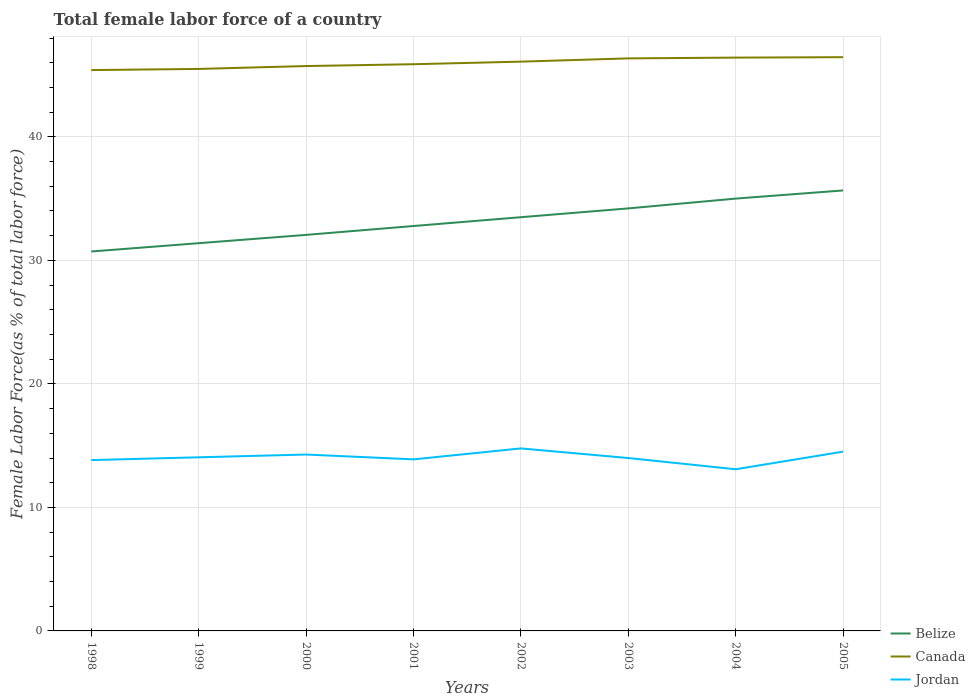Across all years, what is the maximum percentage of female labor force in Belize?
Provide a short and direct response. 30.72. In which year was the percentage of female labor force in Jordan maximum?
Your answer should be very brief. 2004. What is the total percentage of female labor force in Jordan in the graph?
Offer a terse response. -0.52. What is the difference between the highest and the second highest percentage of female labor force in Canada?
Provide a succinct answer. 1.04. What is the difference between the highest and the lowest percentage of female labor force in Canada?
Your answer should be compact. 4. Is the percentage of female labor force in Jordan strictly greater than the percentage of female labor force in Canada over the years?
Provide a short and direct response. Yes. What is the difference between two consecutive major ticks on the Y-axis?
Keep it short and to the point. 10. Does the graph contain grids?
Keep it short and to the point. Yes. How are the legend labels stacked?
Your response must be concise. Vertical. What is the title of the graph?
Your response must be concise. Total female labor force of a country. Does "St. Lucia" appear as one of the legend labels in the graph?
Give a very brief answer. No. What is the label or title of the X-axis?
Your answer should be very brief. Years. What is the label or title of the Y-axis?
Give a very brief answer. Female Labor Force(as % of total labor force). What is the Female Labor Force(as % of total labor force) in Belize in 1998?
Your answer should be compact. 30.72. What is the Female Labor Force(as % of total labor force) in Canada in 1998?
Your response must be concise. 45.41. What is the Female Labor Force(as % of total labor force) of Jordan in 1998?
Your response must be concise. 13.83. What is the Female Labor Force(as % of total labor force) in Belize in 1999?
Provide a short and direct response. 31.39. What is the Female Labor Force(as % of total labor force) of Canada in 1999?
Offer a very short reply. 45.5. What is the Female Labor Force(as % of total labor force) of Jordan in 1999?
Your response must be concise. 14.06. What is the Female Labor Force(as % of total labor force) in Belize in 2000?
Keep it short and to the point. 32.07. What is the Female Labor Force(as % of total labor force) in Canada in 2000?
Your answer should be compact. 45.74. What is the Female Labor Force(as % of total labor force) in Jordan in 2000?
Your response must be concise. 14.28. What is the Female Labor Force(as % of total labor force) of Belize in 2001?
Keep it short and to the point. 32.78. What is the Female Labor Force(as % of total labor force) of Canada in 2001?
Your response must be concise. 45.88. What is the Female Labor Force(as % of total labor force) in Jordan in 2001?
Your answer should be compact. 13.89. What is the Female Labor Force(as % of total labor force) in Belize in 2002?
Your answer should be compact. 33.5. What is the Female Labor Force(as % of total labor force) in Canada in 2002?
Your answer should be compact. 46.09. What is the Female Labor Force(as % of total labor force) of Jordan in 2002?
Provide a short and direct response. 14.78. What is the Female Labor Force(as % of total labor force) in Belize in 2003?
Your response must be concise. 34.21. What is the Female Labor Force(as % of total labor force) in Canada in 2003?
Your answer should be very brief. 46.36. What is the Female Labor Force(as % of total labor force) in Jordan in 2003?
Offer a terse response. 14. What is the Female Labor Force(as % of total labor force) of Belize in 2004?
Provide a succinct answer. 35. What is the Female Labor Force(as % of total labor force) of Canada in 2004?
Keep it short and to the point. 46.42. What is the Female Labor Force(as % of total labor force) in Jordan in 2004?
Provide a short and direct response. 13.09. What is the Female Labor Force(as % of total labor force) in Belize in 2005?
Make the answer very short. 35.66. What is the Female Labor Force(as % of total labor force) of Canada in 2005?
Give a very brief answer. 46.45. What is the Female Labor Force(as % of total labor force) of Jordan in 2005?
Make the answer very short. 14.52. Across all years, what is the maximum Female Labor Force(as % of total labor force) of Belize?
Your response must be concise. 35.66. Across all years, what is the maximum Female Labor Force(as % of total labor force) of Canada?
Provide a short and direct response. 46.45. Across all years, what is the maximum Female Labor Force(as % of total labor force) of Jordan?
Make the answer very short. 14.78. Across all years, what is the minimum Female Labor Force(as % of total labor force) in Belize?
Provide a short and direct response. 30.72. Across all years, what is the minimum Female Labor Force(as % of total labor force) of Canada?
Offer a terse response. 45.41. Across all years, what is the minimum Female Labor Force(as % of total labor force) of Jordan?
Provide a succinct answer. 13.09. What is the total Female Labor Force(as % of total labor force) of Belize in the graph?
Your response must be concise. 265.34. What is the total Female Labor Force(as % of total labor force) in Canada in the graph?
Give a very brief answer. 367.85. What is the total Female Labor Force(as % of total labor force) in Jordan in the graph?
Offer a very short reply. 112.44. What is the difference between the Female Labor Force(as % of total labor force) in Belize in 1998 and that in 1999?
Make the answer very short. -0.67. What is the difference between the Female Labor Force(as % of total labor force) of Canada in 1998 and that in 1999?
Make the answer very short. -0.09. What is the difference between the Female Labor Force(as % of total labor force) of Jordan in 1998 and that in 1999?
Your response must be concise. -0.23. What is the difference between the Female Labor Force(as % of total labor force) in Belize in 1998 and that in 2000?
Provide a succinct answer. -1.34. What is the difference between the Female Labor Force(as % of total labor force) of Canada in 1998 and that in 2000?
Provide a short and direct response. -0.33. What is the difference between the Female Labor Force(as % of total labor force) of Jordan in 1998 and that in 2000?
Provide a succinct answer. -0.45. What is the difference between the Female Labor Force(as % of total labor force) of Belize in 1998 and that in 2001?
Ensure brevity in your answer.  -2.06. What is the difference between the Female Labor Force(as % of total labor force) of Canada in 1998 and that in 2001?
Your response must be concise. -0.47. What is the difference between the Female Labor Force(as % of total labor force) of Jordan in 1998 and that in 2001?
Give a very brief answer. -0.06. What is the difference between the Female Labor Force(as % of total labor force) in Belize in 1998 and that in 2002?
Your response must be concise. -2.78. What is the difference between the Female Labor Force(as % of total labor force) of Canada in 1998 and that in 2002?
Your answer should be compact. -0.68. What is the difference between the Female Labor Force(as % of total labor force) in Jordan in 1998 and that in 2002?
Your answer should be very brief. -0.95. What is the difference between the Female Labor Force(as % of total labor force) of Belize in 1998 and that in 2003?
Provide a succinct answer. -3.49. What is the difference between the Female Labor Force(as % of total labor force) in Canada in 1998 and that in 2003?
Provide a short and direct response. -0.95. What is the difference between the Female Labor Force(as % of total labor force) of Jordan in 1998 and that in 2003?
Provide a short and direct response. -0.17. What is the difference between the Female Labor Force(as % of total labor force) in Belize in 1998 and that in 2004?
Provide a succinct answer. -4.28. What is the difference between the Female Labor Force(as % of total labor force) of Canada in 1998 and that in 2004?
Keep it short and to the point. -1.01. What is the difference between the Female Labor Force(as % of total labor force) of Jordan in 1998 and that in 2004?
Keep it short and to the point. 0.74. What is the difference between the Female Labor Force(as % of total labor force) of Belize in 1998 and that in 2005?
Provide a short and direct response. -4.94. What is the difference between the Female Labor Force(as % of total labor force) in Canada in 1998 and that in 2005?
Keep it short and to the point. -1.04. What is the difference between the Female Labor Force(as % of total labor force) in Jordan in 1998 and that in 2005?
Keep it short and to the point. -0.68. What is the difference between the Female Labor Force(as % of total labor force) in Belize in 1999 and that in 2000?
Ensure brevity in your answer.  -0.67. What is the difference between the Female Labor Force(as % of total labor force) of Canada in 1999 and that in 2000?
Give a very brief answer. -0.23. What is the difference between the Female Labor Force(as % of total labor force) of Jordan in 1999 and that in 2000?
Ensure brevity in your answer.  -0.22. What is the difference between the Female Labor Force(as % of total labor force) of Belize in 1999 and that in 2001?
Make the answer very short. -1.39. What is the difference between the Female Labor Force(as % of total labor force) in Canada in 1999 and that in 2001?
Provide a succinct answer. -0.38. What is the difference between the Female Labor Force(as % of total labor force) of Jordan in 1999 and that in 2001?
Keep it short and to the point. 0.17. What is the difference between the Female Labor Force(as % of total labor force) of Belize in 1999 and that in 2002?
Offer a very short reply. -2.1. What is the difference between the Female Labor Force(as % of total labor force) in Canada in 1999 and that in 2002?
Your response must be concise. -0.59. What is the difference between the Female Labor Force(as % of total labor force) of Jordan in 1999 and that in 2002?
Keep it short and to the point. -0.72. What is the difference between the Female Labor Force(as % of total labor force) in Belize in 1999 and that in 2003?
Ensure brevity in your answer.  -2.82. What is the difference between the Female Labor Force(as % of total labor force) of Canada in 1999 and that in 2003?
Your answer should be compact. -0.85. What is the difference between the Female Labor Force(as % of total labor force) of Jordan in 1999 and that in 2003?
Offer a terse response. 0.06. What is the difference between the Female Labor Force(as % of total labor force) in Belize in 1999 and that in 2004?
Provide a succinct answer. -3.61. What is the difference between the Female Labor Force(as % of total labor force) of Canada in 1999 and that in 2004?
Give a very brief answer. -0.92. What is the difference between the Female Labor Force(as % of total labor force) in Belize in 1999 and that in 2005?
Make the answer very short. -4.27. What is the difference between the Female Labor Force(as % of total labor force) of Canada in 1999 and that in 2005?
Offer a terse response. -0.95. What is the difference between the Female Labor Force(as % of total labor force) in Jordan in 1999 and that in 2005?
Keep it short and to the point. -0.46. What is the difference between the Female Labor Force(as % of total labor force) of Belize in 2000 and that in 2001?
Offer a terse response. -0.72. What is the difference between the Female Labor Force(as % of total labor force) in Canada in 2000 and that in 2001?
Make the answer very short. -0.15. What is the difference between the Female Labor Force(as % of total labor force) of Jordan in 2000 and that in 2001?
Offer a very short reply. 0.39. What is the difference between the Female Labor Force(as % of total labor force) of Belize in 2000 and that in 2002?
Your response must be concise. -1.43. What is the difference between the Female Labor Force(as % of total labor force) in Canada in 2000 and that in 2002?
Your answer should be very brief. -0.36. What is the difference between the Female Labor Force(as % of total labor force) of Jordan in 2000 and that in 2002?
Your answer should be very brief. -0.5. What is the difference between the Female Labor Force(as % of total labor force) in Belize in 2000 and that in 2003?
Make the answer very short. -2.14. What is the difference between the Female Labor Force(as % of total labor force) in Canada in 2000 and that in 2003?
Your answer should be very brief. -0.62. What is the difference between the Female Labor Force(as % of total labor force) of Jordan in 2000 and that in 2003?
Offer a terse response. 0.28. What is the difference between the Female Labor Force(as % of total labor force) of Belize in 2000 and that in 2004?
Offer a very short reply. -2.94. What is the difference between the Female Labor Force(as % of total labor force) of Canada in 2000 and that in 2004?
Keep it short and to the point. -0.68. What is the difference between the Female Labor Force(as % of total labor force) in Jordan in 2000 and that in 2004?
Your response must be concise. 1.19. What is the difference between the Female Labor Force(as % of total labor force) of Belize in 2000 and that in 2005?
Offer a terse response. -3.6. What is the difference between the Female Labor Force(as % of total labor force) in Canada in 2000 and that in 2005?
Provide a short and direct response. -0.72. What is the difference between the Female Labor Force(as % of total labor force) in Jordan in 2000 and that in 2005?
Make the answer very short. -0.23. What is the difference between the Female Labor Force(as % of total labor force) in Belize in 2001 and that in 2002?
Provide a short and direct response. -0.71. What is the difference between the Female Labor Force(as % of total labor force) in Canada in 2001 and that in 2002?
Your answer should be compact. -0.21. What is the difference between the Female Labor Force(as % of total labor force) of Jordan in 2001 and that in 2002?
Your answer should be compact. -0.89. What is the difference between the Female Labor Force(as % of total labor force) in Belize in 2001 and that in 2003?
Provide a short and direct response. -1.43. What is the difference between the Female Labor Force(as % of total labor force) in Canada in 2001 and that in 2003?
Offer a very short reply. -0.47. What is the difference between the Female Labor Force(as % of total labor force) of Jordan in 2001 and that in 2003?
Ensure brevity in your answer.  -0.11. What is the difference between the Female Labor Force(as % of total labor force) of Belize in 2001 and that in 2004?
Ensure brevity in your answer.  -2.22. What is the difference between the Female Labor Force(as % of total labor force) in Canada in 2001 and that in 2004?
Offer a terse response. -0.54. What is the difference between the Female Labor Force(as % of total labor force) of Jordan in 2001 and that in 2004?
Give a very brief answer. 0.8. What is the difference between the Female Labor Force(as % of total labor force) of Belize in 2001 and that in 2005?
Make the answer very short. -2.88. What is the difference between the Female Labor Force(as % of total labor force) in Canada in 2001 and that in 2005?
Offer a very short reply. -0.57. What is the difference between the Female Labor Force(as % of total labor force) in Jordan in 2001 and that in 2005?
Give a very brief answer. -0.62. What is the difference between the Female Labor Force(as % of total labor force) of Belize in 2002 and that in 2003?
Provide a succinct answer. -0.71. What is the difference between the Female Labor Force(as % of total labor force) of Canada in 2002 and that in 2003?
Your answer should be compact. -0.27. What is the difference between the Female Labor Force(as % of total labor force) in Jordan in 2002 and that in 2003?
Make the answer very short. 0.78. What is the difference between the Female Labor Force(as % of total labor force) of Belize in 2002 and that in 2004?
Your response must be concise. -1.51. What is the difference between the Female Labor Force(as % of total labor force) in Canada in 2002 and that in 2004?
Your response must be concise. -0.33. What is the difference between the Female Labor Force(as % of total labor force) of Jordan in 2002 and that in 2004?
Provide a short and direct response. 1.69. What is the difference between the Female Labor Force(as % of total labor force) in Belize in 2002 and that in 2005?
Keep it short and to the point. -2.17. What is the difference between the Female Labor Force(as % of total labor force) in Canada in 2002 and that in 2005?
Offer a very short reply. -0.36. What is the difference between the Female Labor Force(as % of total labor force) in Jordan in 2002 and that in 2005?
Offer a very short reply. 0.26. What is the difference between the Female Labor Force(as % of total labor force) in Belize in 2003 and that in 2004?
Your response must be concise. -0.79. What is the difference between the Female Labor Force(as % of total labor force) in Canada in 2003 and that in 2004?
Offer a very short reply. -0.06. What is the difference between the Female Labor Force(as % of total labor force) of Jordan in 2003 and that in 2004?
Keep it short and to the point. 0.91. What is the difference between the Female Labor Force(as % of total labor force) in Belize in 2003 and that in 2005?
Your answer should be compact. -1.45. What is the difference between the Female Labor Force(as % of total labor force) in Canada in 2003 and that in 2005?
Provide a succinct answer. -0.1. What is the difference between the Female Labor Force(as % of total labor force) in Jordan in 2003 and that in 2005?
Your answer should be compact. -0.52. What is the difference between the Female Labor Force(as % of total labor force) of Belize in 2004 and that in 2005?
Provide a succinct answer. -0.66. What is the difference between the Female Labor Force(as % of total labor force) of Canada in 2004 and that in 2005?
Ensure brevity in your answer.  -0.03. What is the difference between the Female Labor Force(as % of total labor force) in Jordan in 2004 and that in 2005?
Provide a succinct answer. -1.43. What is the difference between the Female Labor Force(as % of total labor force) of Belize in 1998 and the Female Labor Force(as % of total labor force) of Canada in 1999?
Offer a very short reply. -14.78. What is the difference between the Female Labor Force(as % of total labor force) of Belize in 1998 and the Female Labor Force(as % of total labor force) of Jordan in 1999?
Keep it short and to the point. 16.66. What is the difference between the Female Labor Force(as % of total labor force) of Canada in 1998 and the Female Labor Force(as % of total labor force) of Jordan in 1999?
Provide a short and direct response. 31.35. What is the difference between the Female Labor Force(as % of total labor force) of Belize in 1998 and the Female Labor Force(as % of total labor force) of Canada in 2000?
Provide a succinct answer. -15.01. What is the difference between the Female Labor Force(as % of total labor force) of Belize in 1998 and the Female Labor Force(as % of total labor force) of Jordan in 2000?
Your answer should be compact. 16.44. What is the difference between the Female Labor Force(as % of total labor force) of Canada in 1998 and the Female Labor Force(as % of total labor force) of Jordan in 2000?
Offer a very short reply. 31.13. What is the difference between the Female Labor Force(as % of total labor force) of Belize in 1998 and the Female Labor Force(as % of total labor force) of Canada in 2001?
Offer a terse response. -15.16. What is the difference between the Female Labor Force(as % of total labor force) in Belize in 1998 and the Female Labor Force(as % of total labor force) in Jordan in 2001?
Provide a succinct answer. 16.83. What is the difference between the Female Labor Force(as % of total labor force) of Canada in 1998 and the Female Labor Force(as % of total labor force) of Jordan in 2001?
Your answer should be compact. 31.52. What is the difference between the Female Labor Force(as % of total labor force) in Belize in 1998 and the Female Labor Force(as % of total labor force) in Canada in 2002?
Keep it short and to the point. -15.37. What is the difference between the Female Labor Force(as % of total labor force) in Belize in 1998 and the Female Labor Force(as % of total labor force) in Jordan in 2002?
Offer a terse response. 15.94. What is the difference between the Female Labor Force(as % of total labor force) of Canada in 1998 and the Female Labor Force(as % of total labor force) of Jordan in 2002?
Your response must be concise. 30.63. What is the difference between the Female Labor Force(as % of total labor force) of Belize in 1998 and the Female Labor Force(as % of total labor force) of Canada in 2003?
Offer a terse response. -15.64. What is the difference between the Female Labor Force(as % of total labor force) of Belize in 1998 and the Female Labor Force(as % of total labor force) of Jordan in 2003?
Provide a short and direct response. 16.72. What is the difference between the Female Labor Force(as % of total labor force) in Canada in 1998 and the Female Labor Force(as % of total labor force) in Jordan in 2003?
Your answer should be compact. 31.41. What is the difference between the Female Labor Force(as % of total labor force) in Belize in 1998 and the Female Labor Force(as % of total labor force) in Canada in 2004?
Ensure brevity in your answer.  -15.7. What is the difference between the Female Labor Force(as % of total labor force) in Belize in 1998 and the Female Labor Force(as % of total labor force) in Jordan in 2004?
Give a very brief answer. 17.63. What is the difference between the Female Labor Force(as % of total labor force) of Canada in 1998 and the Female Labor Force(as % of total labor force) of Jordan in 2004?
Offer a terse response. 32.32. What is the difference between the Female Labor Force(as % of total labor force) in Belize in 1998 and the Female Labor Force(as % of total labor force) in Canada in 2005?
Offer a terse response. -15.73. What is the difference between the Female Labor Force(as % of total labor force) in Belize in 1998 and the Female Labor Force(as % of total labor force) in Jordan in 2005?
Offer a terse response. 16.21. What is the difference between the Female Labor Force(as % of total labor force) in Canada in 1998 and the Female Labor Force(as % of total labor force) in Jordan in 2005?
Your response must be concise. 30.89. What is the difference between the Female Labor Force(as % of total labor force) of Belize in 1999 and the Female Labor Force(as % of total labor force) of Canada in 2000?
Ensure brevity in your answer.  -14.34. What is the difference between the Female Labor Force(as % of total labor force) in Belize in 1999 and the Female Labor Force(as % of total labor force) in Jordan in 2000?
Provide a succinct answer. 17.11. What is the difference between the Female Labor Force(as % of total labor force) of Canada in 1999 and the Female Labor Force(as % of total labor force) of Jordan in 2000?
Your answer should be compact. 31.22. What is the difference between the Female Labor Force(as % of total labor force) of Belize in 1999 and the Female Labor Force(as % of total labor force) of Canada in 2001?
Make the answer very short. -14.49. What is the difference between the Female Labor Force(as % of total labor force) in Belize in 1999 and the Female Labor Force(as % of total labor force) in Jordan in 2001?
Your response must be concise. 17.5. What is the difference between the Female Labor Force(as % of total labor force) of Canada in 1999 and the Female Labor Force(as % of total labor force) of Jordan in 2001?
Provide a succinct answer. 31.61. What is the difference between the Female Labor Force(as % of total labor force) of Belize in 1999 and the Female Labor Force(as % of total labor force) of Canada in 2002?
Make the answer very short. -14.7. What is the difference between the Female Labor Force(as % of total labor force) of Belize in 1999 and the Female Labor Force(as % of total labor force) of Jordan in 2002?
Offer a terse response. 16.62. What is the difference between the Female Labor Force(as % of total labor force) of Canada in 1999 and the Female Labor Force(as % of total labor force) of Jordan in 2002?
Your answer should be compact. 30.73. What is the difference between the Female Labor Force(as % of total labor force) in Belize in 1999 and the Female Labor Force(as % of total labor force) in Canada in 2003?
Provide a succinct answer. -14.96. What is the difference between the Female Labor Force(as % of total labor force) in Belize in 1999 and the Female Labor Force(as % of total labor force) in Jordan in 2003?
Provide a succinct answer. 17.4. What is the difference between the Female Labor Force(as % of total labor force) in Canada in 1999 and the Female Labor Force(as % of total labor force) in Jordan in 2003?
Keep it short and to the point. 31.5. What is the difference between the Female Labor Force(as % of total labor force) of Belize in 1999 and the Female Labor Force(as % of total labor force) of Canada in 2004?
Your answer should be compact. -15.03. What is the difference between the Female Labor Force(as % of total labor force) of Belize in 1999 and the Female Labor Force(as % of total labor force) of Jordan in 2004?
Make the answer very short. 18.3. What is the difference between the Female Labor Force(as % of total labor force) in Canada in 1999 and the Female Labor Force(as % of total labor force) in Jordan in 2004?
Offer a terse response. 32.41. What is the difference between the Female Labor Force(as % of total labor force) of Belize in 1999 and the Female Labor Force(as % of total labor force) of Canada in 2005?
Ensure brevity in your answer.  -15.06. What is the difference between the Female Labor Force(as % of total labor force) in Belize in 1999 and the Female Labor Force(as % of total labor force) in Jordan in 2005?
Provide a succinct answer. 16.88. What is the difference between the Female Labor Force(as % of total labor force) of Canada in 1999 and the Female Labor Force(as % of total labor force) of Jordan in 2005?
Your response must be concise. 30.99. What is the difference between the Female Labor Force(as % of total labor force) of Belize in 2000 and the Female Labor Force(as % of total labor force) of Canada in 2001?
Provide a succinct answer. -13.82. What is the difference between the Female Labor Force(as % of total labor force) of Belize in 2000 and the Female Labor Force(as % of total labor force) of Jordan in 2001?
Your answer should be compact. 18.18. What is the difference between the Female Labor Force(as % of total labor force) in Canada in 2000 and the Female Labor Force(as % of total labor force) in Jordan in 2001?
Your response must be concise. 31.85. What is the difference between the Female Labor Force(as % of total labor force) of Belize in 2000 and the Female Labor Force(as % of total labor force) of Canada in 2002?
Keep it short and to the point. -14.03. What is the difference between the Female Labor Force(as % of total labor force) of Belize in 2000 and the Female Labor Force(as % of total labor force) of Jordan in 2002?
Your answer should be compact. 17.29. What is the difference between the Female Labor Force(as % of total labor force) of Canada in 2000 and the Female Labor Force(as % of total labor force) of Jordan in 2002?
Your answer should be compact. 30.96. What is the difference between the Female Labor Force(as % of total labor force) in Belize in 2000 and the Female Labor Force(as % of total labor force) in Canada in 2003?
Make the answer very short. -14.29. What is the difference between the Female Labor Force(as % of total labor force) of Belize in 2000 and the Female Labor Force(as % of total labor force) of Jordan in 2003?
Offer a very short reply. 18.07. What is the difference between the Female Labor Force(as % of total labor force) in Canada in 2000 and the Female Labor Force(as % of total labor force) in Jordan in 2003?
Your response must be concise. 31.74. What is the difference between the Female Labor Force(as % of total labor force) of Belize in 2000 and the Female Labor Force(as % of total labor force) of Canada in 2004?
Make the answer very short. -14.35. What is the difference between the Female Labor Force(as % of total labor force) of Belize in 2000 and the Female Labor Force(as % of total labor force) of Jordan in 2004?
Keep it short and to the point. 18.98. What is the difference between the Female Labor Force(as % of total labor force) of Canada in 2000 and the Female Labor Force(as % of total labor force) of Jordan in 2004?
Keep it short and to the point. 32.65. What is the difference between the Female Labor Force(as % of total labor force) in Belize in 2000 and the Female Labor Force(as % of total labor force) in Canada in 2005?
Your response must be concise. -14.39. What is the difference between the Female Labor Force(as % of total labor force) of Belize in 2000 and the Female Labor Force(as % of total labor force) of Jordan in 2005?
Your answer should be very brief. 17.55. What is the difference between the Female Labor Force(as % of total labor force) of Canada in 2000 and the Female Labor Force(as % of total labor force) of Jordan in 2005?
Offer a very short reply. 31.22. What is the difference between the Female Labor Force(as % of total labor force) in Belize in 2001 and the Female Labor Force(as % of total labor force) in Canada in 2002?
Give a very brief answer. -13.31. What is the difference between the Female Labor Force(as % of total labor force) of Belize in 2001 and the Female Labor Force(as % of total labor force) of Jordan in 2002?
Ensure brevity in your answer.  18.01. What is the difference between the Female Labor Force(as % of total labor force) of Canada in 2001 and the Female Labor Force(as % of total labor force) of Jordan in 2002?
Offer a very short reply. 31.11. What is the difference between the Female Labor Force(as % of total labor force) of Belize in 2001 and the Female Labor Force(as % of total labor force) of Canada in 2003?
Make the answer very short. -13.57. What is the difference between the Female Labor Force(as % of total labor force) of Belize in 2001 and the Female Labor Force(as % of total labor force) of Jordan in 2003?
Your response must be concise. 18.79. What is the difference between the Female Labor Force(as % of total labor force) in Canada in 2001 and the Female Labor Force(as % of total labor force) in Jordan in 2003?
Ensure brevity in your answer.  31.89. What is the difference between the Female Labor Force(as % of total labor force) of Belize in 2001 and the Female Labor Force(as % of total labor force) of Canada in 2004?
Ensure brevity in your answer.  -13.64. What is the difference between the Female Labor Force(as % of total labor force) in Belize in 2001 and the Female Labor Force(as % of total labor force) in Jordan in 2004?
Offer a terse response. 19.69. What is the difference between the Female Labor Force(as % of total labor force) in Canada in 2001 and the Female Labor Force(as % of total labor force) in Jordan in 2004?
Your response must be concise. 32.79. What is the difference between the Female Labor Force(as % of total labor force) of Belize in 2001 and the Female Labor Force(as % of total labor force) of Canada in 2005?
Provide a succinct answer. -13.67. What is the difference between the Female Labor Force(as % of total labor force) of Belize in 2001 and the Female Labor Force(as % of total labor force) of Jordan in 2005?
Give a very brief answer. 18.27. What is the difference between the Female Labor Force(as % of total labor force) of Canada in 2001 and the Female Labor Force(as % of total labor force) of Jordan in 2005?
Your answer should be compact. 31.37. What is the difference between the Female Labor Force(as % of total labor force) of Belize in 2002 and the Female Labor Force(as % of total labor force) of Canada in 2003?
Offer a very short reply. -12.86. What is the difference between the Female Labor Force(as % of total labor force) in Belize in 2002 and the Female Labor Force(as % of total labor force) in Jordan in 2003?
Offer a very short reply. 19.5. What is the difference between the Female Labor Force(as % of total labor force) in Canada in 2002 and the Female Labor Force(as % of total labor force) in Jordan in 2003?
Give a very brief answer. 32.09. What is the difference between the Female Labor Force(as % of total labor force) in Belize in 2002 and the Female Labor Force(as % of total labor force) in Canada in 2004?
Offer a very short reply. -12.92. What is the difference between the Female Labor Force(as % of total labor force) in Belize in 2002 and the Female Labor Force(as % of total labor force) in Jordan in 2004?
Your response must be concise. 20.41. What is the difference between the Female Labor Force(as % of total labor force) in Canada in 2002 and the Female Labor Force(as % of total labor force) in Jordan in 2004?
Offer a terse response. 33. What is the difference between the Female Labor Force(as % of total labor force) in Belize in 2002 and the Female Labor Force(as % of total labor force) in Canada in 2005?
Offer a terse response. -12.96. What is the difference between the Female Labor Force(as % of total labor force) in Belize in 2002 and the Female Labor Force(as % of total labor force) in Jordan in 2005?
Give a very brief answer. 18.98. What is the difference between the Female Labor Force(as % of total labor force) of Canada in 2002 and the Female Labor Force(as % of total labor force) of Jordan in 2005?
Offer a very short reply. 31.58. What is the difference between the Female Labor Force(as % of total labor force) of Belize in 2003 and the Female Labor Force(as % of total labor force) of Canada in 2004?
Offer a terse response. -12.21. What is the difference between the Female Labor Force(as % of total labor force) in Belize in 2003 and the Female Labor Force(as % of total labor force) in Jordan in 2004?
Your answer should be compact. 21.12. What is the difference between the Female Labor Force(as % of total labor force) of Canada in 2003 and the Female Labor Force(as % of total labor force) of Jordan in 2004?
Provide a succinct answer. 33.27. What is the difference between the Female Labor Force(as % of total labor force) in Belize in 2003 and the Female Labor Force(as % of total labor force) in Canada in 2005?
Keep it short and to the point. -12.24. What is the difference between the Female Labor Force(as % of total labor force) of Belize in 2003 and the Female Labor Force(as % of total labor force) of Jordan in 2005?
Give a very brief answer. 19.69. What is the difference between the Female Labor Force(as % of total labor force) in Canada in 2003 and the Female Labor Force(as % of total labor force) in Jordan in 2005?
Offer a very short reply. 31.84. What is the difference between the Female Labor Force(as % of total labor force) in Belize in 2004 and the Female Labor Force(as % of total labor force) in Canada in 2005?
Provide a succinct answer. -11.45. What is the difference between the Female Labor Force(as % of total labor force) of Belize in 2004 and the Female Labor Force(as % of total labor force) of Jordan in 2005?
Your answer should be compact. 20.49. What is the difference between the Female Labor Force(as % of total labor force) in Canada in 2004 and the Female Labor Force(as % of total labor force) in Jordan in 2005?
Provide a succinct answer. 31.9. What is the average Female Labor Force(as % of total labor force) in Belize per year?
Ensure brevity in your answer.  33.17. What is the average Female Labor Force(as % of total labor force) of Canada per year?
Provide a short and direct response. 45.98. What is the average Female Labor Force(as % of total labor force) of Jordan per year?
Provide a short and direct response. 14.06. In the year 1998, what is the difference between the Female Labor Force(as % of total labor force) of Belize and Female Labor Force(as % of total labor force) of Canada?
Your answer should be compact. -14.69. In the year 1998, what is the difference between the Female Labor Force(as % of total labor force) in Belize and Female Labor Force(as % of total labor force) in Jordan?
Make the answer very short. 16.89. In the year 1998, what is the difference between the Female Labor Force(as % of total labor force) in Canada and Female Labor Force(as % of total labor force) in Jordan?
Provide a succinct answer. 31.58. In the year 1999, what is the difference between the Female Labor Force(as % of total labor force) of Belize and Female Labor Force(as % of total labor force) of Canada?
Keep it short and to the point. -14.11. In the year 1999, what is the difference between the Female Labor Force(as % of total labor force) in Belize and Female Labor Force(as % of total labor force) in Jordan?
Keep it short and to the point. 17.34. In the year 1999, what is the difference between the Female Labor Force(as % of total labor force) of Canada and Female Labor Force(as % of total labor force) of Jordan?
Keep it short and to the point. 31.44. In the year 2000, what is the difference between the Female Labor Force(as % of total labor force) of Belize and Female Labor Force(as % of total labor force) of Canada?
Give a very brief answer. -13.67. In the year 2000, what is the difference between the Female Labor Force(as % of total labor force) in Belize and Female Labor Force(as % of total labor force) in Jordan?
Your response must be concise. 17.78. In the year 2000, what is the difference between the Female Labor Force(as % of total labor force) of Canada and Female Labor Force(as % of total labor force) of Jordan?
Your answer should be very brief. 31.45. In the year 2001, what is the difference between the Female Labor Force(as % of total labor force) in Belize and Female Labor Force(as % of total labor force) in Canada?
Offer a terse response. -13.1. In the year 2001, what is the difference between the Female Labor Force(as % of total labor force) in Belize and Female Labor Force(as % of total labor force) in Jordan?
Your response must be concise. 18.89. In the year 2001, what is the difference between the Female Labor Force(as % of total labor force) of Canada and Female Labor Force(as % of total labor force) of Jordan?
Offer a terse response. 31.99. In the year 2002, what is the difference between the Female Labor Force(as % of total labor force) in Belize and Female Labor Force(as % of total labor force) in Canada?
Give a very brief answer. -12.59. In the year 2002, what is the difference between the Female Labor Force(as % of total labor force) of Belize and Female Labor Force(as % of total labor force) of Jordan?
Make the answer very short. 18.72. In the year 2002, what is the difference between the Female Labor Force(as % of total labor force) of Canada and Female Labor Force(as % of total labor force) of Jordan?
Your answer should be compact. 31.32. In the year 2003, what is the difference between the Female Labor Force(as % of total labor force) of Belize and Female Labor Force(as % of total labor force) of Canada?
Your answer should be very brief. -12.15. In the year 2003, what is the difference between the Female Labor Force(as % of total labor force) of Belize and Female Labor Force(as % of total labor force) of Jordan?
Ensure brevity in your answer.  20.21. In the year 2003, what is the difference between the Female Labor Force(as % of total labor force) in Canada and Female Labor Force(as % of total labor force) in Jordan?
Your answer should be very brief. 32.36. In the year 2004, what is the difference between the Female Labor Force(as % of total labor force) of Belize and Female Labor Force(as % of total labor force) of Canada?
Give a very brief answer. -11.42. In the year 2004, what is the difference between the Female Labor Force(as % of total labor force) of Belize and Female Labor Force(as % of total labor force) of Jordan?
Offer a very short reply. 21.91. In the year 2004, what is the difference between the Female Labor Force(as % of total labor force) in Canada and Female Labor Force(as % of total labor force) in Jordan?
Your answer should be compact. 33.33. In the year 2005, what is the difference between the Female Labor Force(as % of total labor force) of Belize and Female Labor Force(as % of total labor force) of Canada?
Offer a very short reply. -10.79. In the year 2005, what is the difference between the Female Labor Force(as % of total labor force) in Belize and Female Labor Force(as % of total labor force) in Jordan?
Give a very brief answer. 21.15. In the year 2005, what is the difference between the Female Labor Force(as % of total labor force) in Canada and Female Labor Force(as % of total labor force) in Jordan?
Make the answer very short. 31.94. What is the ratio of the Female Labor Force(as % of total labor force) of Belize in 1998 to that in 1999?
Ensure brevity in your answer.  0.98. What is the ratio of the Female Labor Force(as % of total labor force) of Jordan in 1998 to that in 1999?
Keep it short and to the point. 0.98. What is the ratio of the Female Labor Force(as % of total labor force) in Belize in 1998 to that in 2000?
Offer a very short reply. 0.96. What is the ratio of the Female Labor Force(as % of total labor force) in Jordan in 1998 to that in 2000?
Provide a succinct answer. 0.97. What is the ratio of the Female Labor Force(as % of total labor force) of Belize in 1998 to that in 2001?
Offer a terse response. 0.94. What is the ratio of the Female Labor Force(as % of total labor force) of Canada in 1998 to that in 2001?
Provide a short and direct response. 0.99. What is the ratio of the Female Labor Force(as % of total labor force) in Jordan in 1998 to that in 2001?
Your answer should be very brief. 1. What is the ratio of the Female Labor Force(as % of total labor force) of Belize in 1998 to that in 2002?
Ensure brevity in your answer.  0.92. What is the ratio of the Female Labor Force(as % of total labor force) in Canada in 1998 to that in 2002?
Provide a short and direct response. 0.99. What is the ratio of the Female Labor Force(as % of total labor force) in Jordan in 1998 to that in 2002?
Your answer should be very brief. 0.94. What is the ratio of the Female Labor Force(as % of total labor force) of Belize in 1998 to that in 2003?
Your answer should be compact. 0.9. What is the ratio of the Female Labor Force(as % of total labor force) in Canada in 1998 to that in 2003?
Offer a terse response. 0.98. What is the ratio of the Female Labor Force(as % of total labor force) of Belize in 1998 to that in 2004?
Your answer should be compact. 0.88. What is the ratio of the Female Labor Force(as % of total labor force) in Canada in 1998 to that in 2004?
Give a very brief answer. 0.98. What is the ratio of the Female Labor Force(as % of total labor force) of Jordan in 1998 to that in 2004?
Provide a short and direct response. 1.06. What is the ratio of the Female Labor Force(as % of total labor force) in Belize in 1998 to that in 2005?
Offer a very short reply. 0.86. What is the ratio of the Female Labor Force(as % of total labor force) of Canada in 1998 to that in 2005?
Your answer should be compact. 0.98. What is the ratio of the Female Labor Force(as % of total labor force) in Jordan in 1998 to that in 2005?
Give a very brief answer. 0.95. What is the ratio of the Female Labor Force(as % of total labor force) of Belize in 1999 to that in 2000?
Offer a terse response. 0.98. What is the ratio of the Female Labor Force(as % of total labor force) of Canada in 1999 to that in 2000?
Offer a terse response. 0.99. What is the ratio of the Female Labor Force(as % of total labor force) in Jordan in 1999 to that in 2000?
Your response must be concise. 0.98. What is the ratio of the Female Labor Force(as % of total labor force) in Belize in 1999 to that in 2001?
Ensure brevity in your answer.  0.96. What is the ratio of the Female Labor Force(as % of total labor force) of Canada in 1999 to that in 2001?
Provide a short and direct response. 0.99. What is the ratio of the Female Labor Force(as % of total labor force) in Jordan in 1999 to that in 2001?
Your answer should be very brief. 1.01. What is the ratio of the Female Labor Force(as % of total labor force) of Belize in 1999 to that in 2002?
Ensure brevity in your answer.  0.94. What is the ratio of the Female Labor Force(as % of total labor force) of Canada in 1999 to that in 2002?
Offer a terse response. 0.99. What is the ratio of the Female Labor Force(as % of total labor force) of Jordan in 1999 to that in 2002?
Give a very brief answer. 0.95. What is the ratio of the Female Labor Force(as % of total labor force) in Belize in 1999 to that in 2003?
Ensure brevity in your answer.  0.92. What is the ratio of the Female Labor Force(as % of total labor force) of Canada in 1999 to that in 2003?
Give a very brief answer. 0.98. What is the ratio of the Female Labor Force(as % of total labor force) in Belize in 1999 to that in 2004?
Keep it short and to the point. 0.9. What is the ratio of the Female Labor Force(as % of total labor force) in Canada in 1999 to that in 2004?
Provide a succinct answer. 0.98. What is the ratio of the Female Labor Force(as % of total labor force) of Jordan in 1999 to that in 2004?
Your answer should be very brief. 1.07. What is the ratio of the Female Labor Force(as % of total labor force) in Belize in 1999 to that in 2005?
Offer a very short reply. 0.88. What is the ratio of the Female Labor Force(as % of total labor force) in Canada in 1999 to that in 2005?
Make the answer very short. 0.98. What is the ratio of the Female Labor Force(as % of total labor force) of Jordan in 1999 to that in 2005?
Offer a very short reply. 0.97. What is the ratio of the Female Labor Force(as % of total labor force) in Belize in 2000 to that in 2001?
Give a very brief answer. 0.98. What is the ratio of the Female Labor Force(as % of total labor force) of Canada in 2000 to that in 2001?
Give a very brief answer. 1. What is the ratio of the Female Labor Force(as % of total labor force) in Jordan in 2000 to that in 2001?
Keep it short and to the point. 1.03. What is the ratio of the Female Labor Force(as % of total labor force) in Belize in 2000 to that in 2002?
Keep it short and to the point. 0.96. What is the ratio of the Female Labor Force(as % of total labor force) in Canada in 2000 to that in 2002?
Provide a succinct answer. 0.99. What is the ratio of the Female Labor Force(as % of total labor force) of Jordan in 2000 to that in 2002?
Offer a terse response. 0.97. What is the ratio of the Female Labor Force(as % of total labor force) of Belize in 2000 to that in 2003?
Keep it short and to the point. 0.94. What is the ratio of the Female Labor Force(as % of total labor force) of Canada in 2000 to that in 2003?
Provide a succinct answer. 0.99. What is the ratio of the Female Labor Force(as % of total labor force) in Jordan in 2000 to that in 2003?
Ensure brevity in your answer.  1.02. What is the ratio of the Female Labor Force(as % of total labor force) of Belize in 2000 to that in 2004?
Make the answer very short. 0.92. What is the ratio of the Female Labor Force(as % of total labor force) of Canada in 2000 to that in 2004?
Keep it short and to the point. 0.99. What is the ratio of the Female Labor Force(as % of total labor force) of Jordan in 2000 to that in 2004?
Give a very brief answer. 1.09. What is the ratio of the Female Labor Force(as % of total labor force) in Belize in 2000 to that in 2005?
Offer a terse response. 0.9. What is the ratio of the Female Labor Force(as % of total labor force) of Canada in 2000 to that in 2005?
Give a very brief answer. 0.98. What is the ratio of the Female Labor Force(as % of total labor force) in Jordan in 2000 to that in 2005?
Ensure brevity in your answer.  0.98. What is the ratio of the Female Labor Force(as % of total labor force) of Belize in 2001 to that in 2002?
Provide a succinct answer. 0.98. What is the ratio of the Female Labor Force(as % of total labor force) of Canada in 2001 to that in 2002?
Your answer should be very brief. 1. What is the ratio of the Female Labor Force(as % of total labor force) of Jordan in 2001 to that in 2002?
Your answer should be compact. 0.94. What is the ratio of the Female Labor Force(as % of total labor force) in Canada in 2001 to that in 2003?
Ensure brevity in your answer.  0.99. What is the ratio of the Female Labor Force(as % of total labor force) of Jordan in 2001 to that in 2003?
Provide a succinct answer. 0.99. What is the ratio of the Female Labor Force(as % of total labor force) in Belize in 2001 to that in 2004?
Provide a short and direct response. 0.94. What is the ratio of the Female Labor Force(as % of total labor force) of Canada in 2001 to that in 2004?
Keep it short and to the point. 0.99. What is the ratio of the Female Labor Force(as % of total labor force) in Jordan in 2001 to that in 2004?
Keep it short and to the point. 1.06. What is the ratio of the Female Labor Force(as % of total labor force) in Belize in 2001 to that in 2005?
Provide a short and direct response. 0.92. What is the ratio of the Female Labor Force(as % of total labor force) in Belize in 2002 to that in 2003?
Keep it short and to the point. 0.98. What is the ratio of the Female Labor Force(as % of total labor force) of Jordan in 2002 to that in 2003?
Ensure brevity in your answer.  1.06. What is the ratio of the Female Labor Force(as % of total labor force) of Jordan in 2002 to that in 2004?
Offer a terse response. 1.13. What is the ratio of the Female Labor Force(as % of total labor force) in Belize in 2002 to that in 2005?
Offer a terse response. 0.94. What is the ratio of the Female Labor Force(as % of total labor force) in Jordan in 2002 to that in 2005?
Provide a short and direct response. 1.02. What is the ratio of the Female Labor Force(as % of total labor force) of Belize in 2003 to that in 2004?
Your answer should be very brief. 0.98. What is the ratio of the Female Labor Force(as % of total labor force) of Canada in 2003 to that in 2004?
Make the answer very short. 1. What is the ratio of the Female Labor Force(as % of total labor force) of Jordan in 2003 to that in 2004?
Your response must be concise. 1.07. What is the ratio of the Female Labor Force(as % of total labor force) in Belize in 2003 to that in 2005?
Offer a terse response. 0.96. What is the ratio of the Female Labor Force(as % of total labor force) in Canada in 2003 to that in 2005?
Your answer should be very brief. 1. What is the ratio of the Female Labor Force(as % of total labor force) of Jordan in 2003 to that in 2005?
Give a very brief answer. 0.96. What is the ratio of the Female Labor Force(as % of total labor force) of Belize in 2004 to that in 2005?
Your answer should be very brief. 0.98. What is the ratio of the Female Labor Force(as % of total labor force) of Jordan in 2004 to that in 2005?
Your response must be concise. 0.9. What is the difference between the highest and the second highest Female Labor Force(as % of total labor force) in Belize?
Offer a very short reply. 0.66. What is the difference between the highest and the second highest Female Labor Force(as % of total labor force) of Canada?
Provide a succinct answer. 0.03. What is the difference between the highest and the second highest Female Labor Force(as % of total labor force) of Jordan?
Provide a short and direct response. 0.26. What is the difference between the highest and the lowest Female Labor Force(as % of total labor force) of Belize?
Give a very brief answer. 4.94. What is the difference between the highest and the lowest Female Labor Force(as % of total labor force) in Canada?
Give a very brief answer. 1.04. What is the difference between the highest and the lowest Female Labor Force(as % of total labor force) in Jordan?
Offer a terse response. 1.69. 